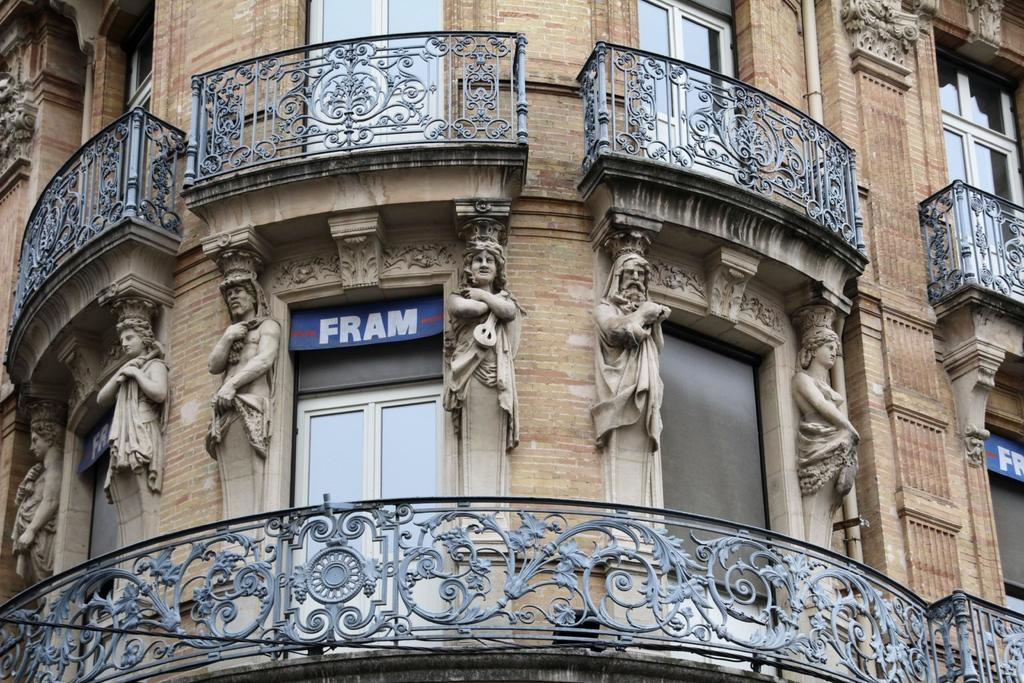What is the main structure visible in the image? There is a building in the image. Are there any additional features on the building? Yes, there are statues attached to the building. What type of sound can be heard coming from the statues in the image? There is no sound present in the image, as it is a static representation of the building and statues. 